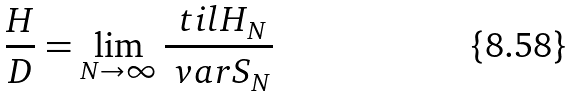<formula> <loc_0><loc_0><loc_500><loc_500>\frac { H } { D } = \lim _ { N \to \infty } \frac { \ t i l H _ { N } } { \ v a r S _ { N } }</formula> 